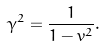Convert formula to latex. <formula><loc_0><loc_0><loc_500><loc_500>\gamma ^ { 2 } = { \frac { 1 } { 1 - v ^ { 2 } } } .</formula> 